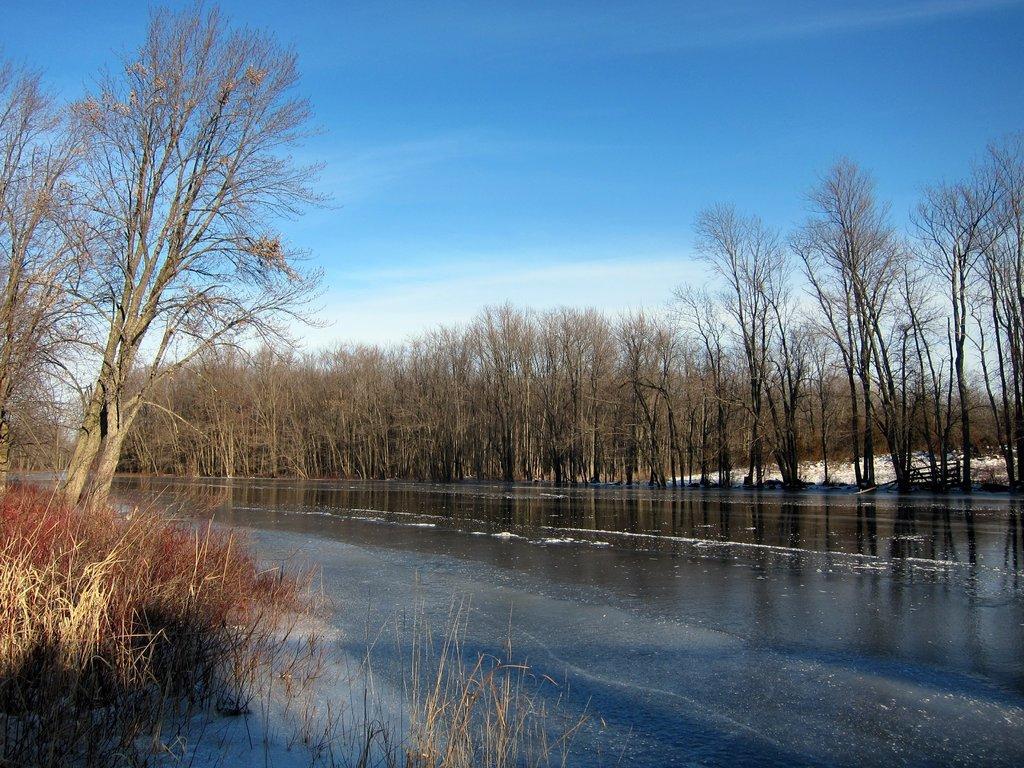How would you summarize this image in a sentence or two? In this image we can see the water. And we can see the dried trees and grass. And we can see the clouds in the sky. 